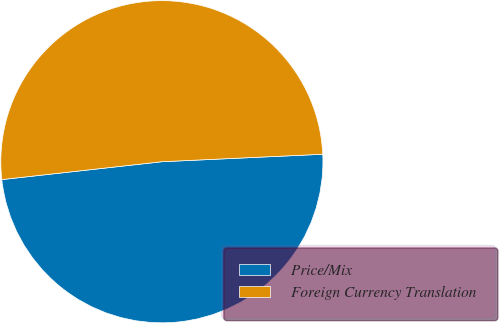<chart> <loc_0><loc_0><loc_500><loc_500><pie_chart><fcel>Price/Mix<fcel>Foreign Currency Translation<nl><fcel>48.97%<fcel>51.03%<nl></chart> 